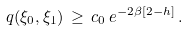<formula> <loc_0><loc_0><loc_500><loc_500>q ( \xi _ { 0 } , \xi _ { 1 } ) \, \geq \, c _ { 0 } \, e ^ { - 2 \beta [ 2 - h ] } \, .</formula> 